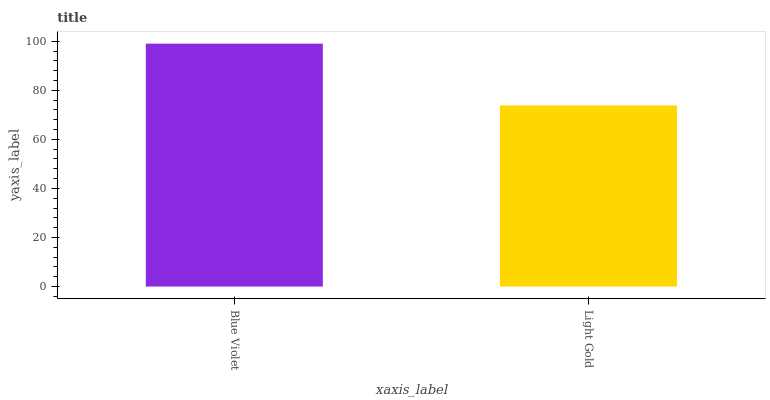Is Light Gold the minimum?
Answer yes or no. Yes. Is Blue Violet the maximum?
Answer yes or no. Yes. Is Light Gold the maximum?
Answer yes or no. No. Is Blue Violet greater than Light Gold?
Answer yes or no. Yes. Is Light Gold less than Blue Violet?
Answer yes or no. Yes. Is Light Gold greater than Blue Violet?
Answer yes or no. No. Is Blue Violet less than Light Gold?
Answer yes or no. No. Is Blue Violet the high median?
Answer yes or no. Yes. Is Light Gold the low median?
Answer yes or no. Yes. Is Light Gold the high median?
Answer yes or no. No. Is Blue Violet the low median?
Answer yes or no. No. 